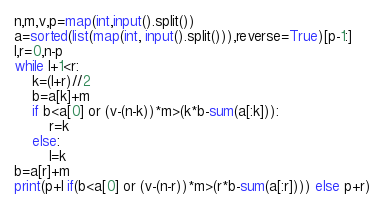<code> <loc_0><loc_0><loc_500><loc_500><_Python_>n,m,v,p=map(int,input().split())
a=sorted(list(map(int, input().split())),reverse=True)[p-1:]
l,r=0,n-p
while l+1<r:
    k=(l+r)//2
    b=a[k]+m
    if b<a[0] or (v-(n-k))*m>(k*b-sum(a[:k])):
        r=k
    else:
        l=k
b=a[r]+m
print(p+l if(b<a[0] or (v-(n-r))*m>(r*b-sum(a[:r]))) else p+r)
</code> 